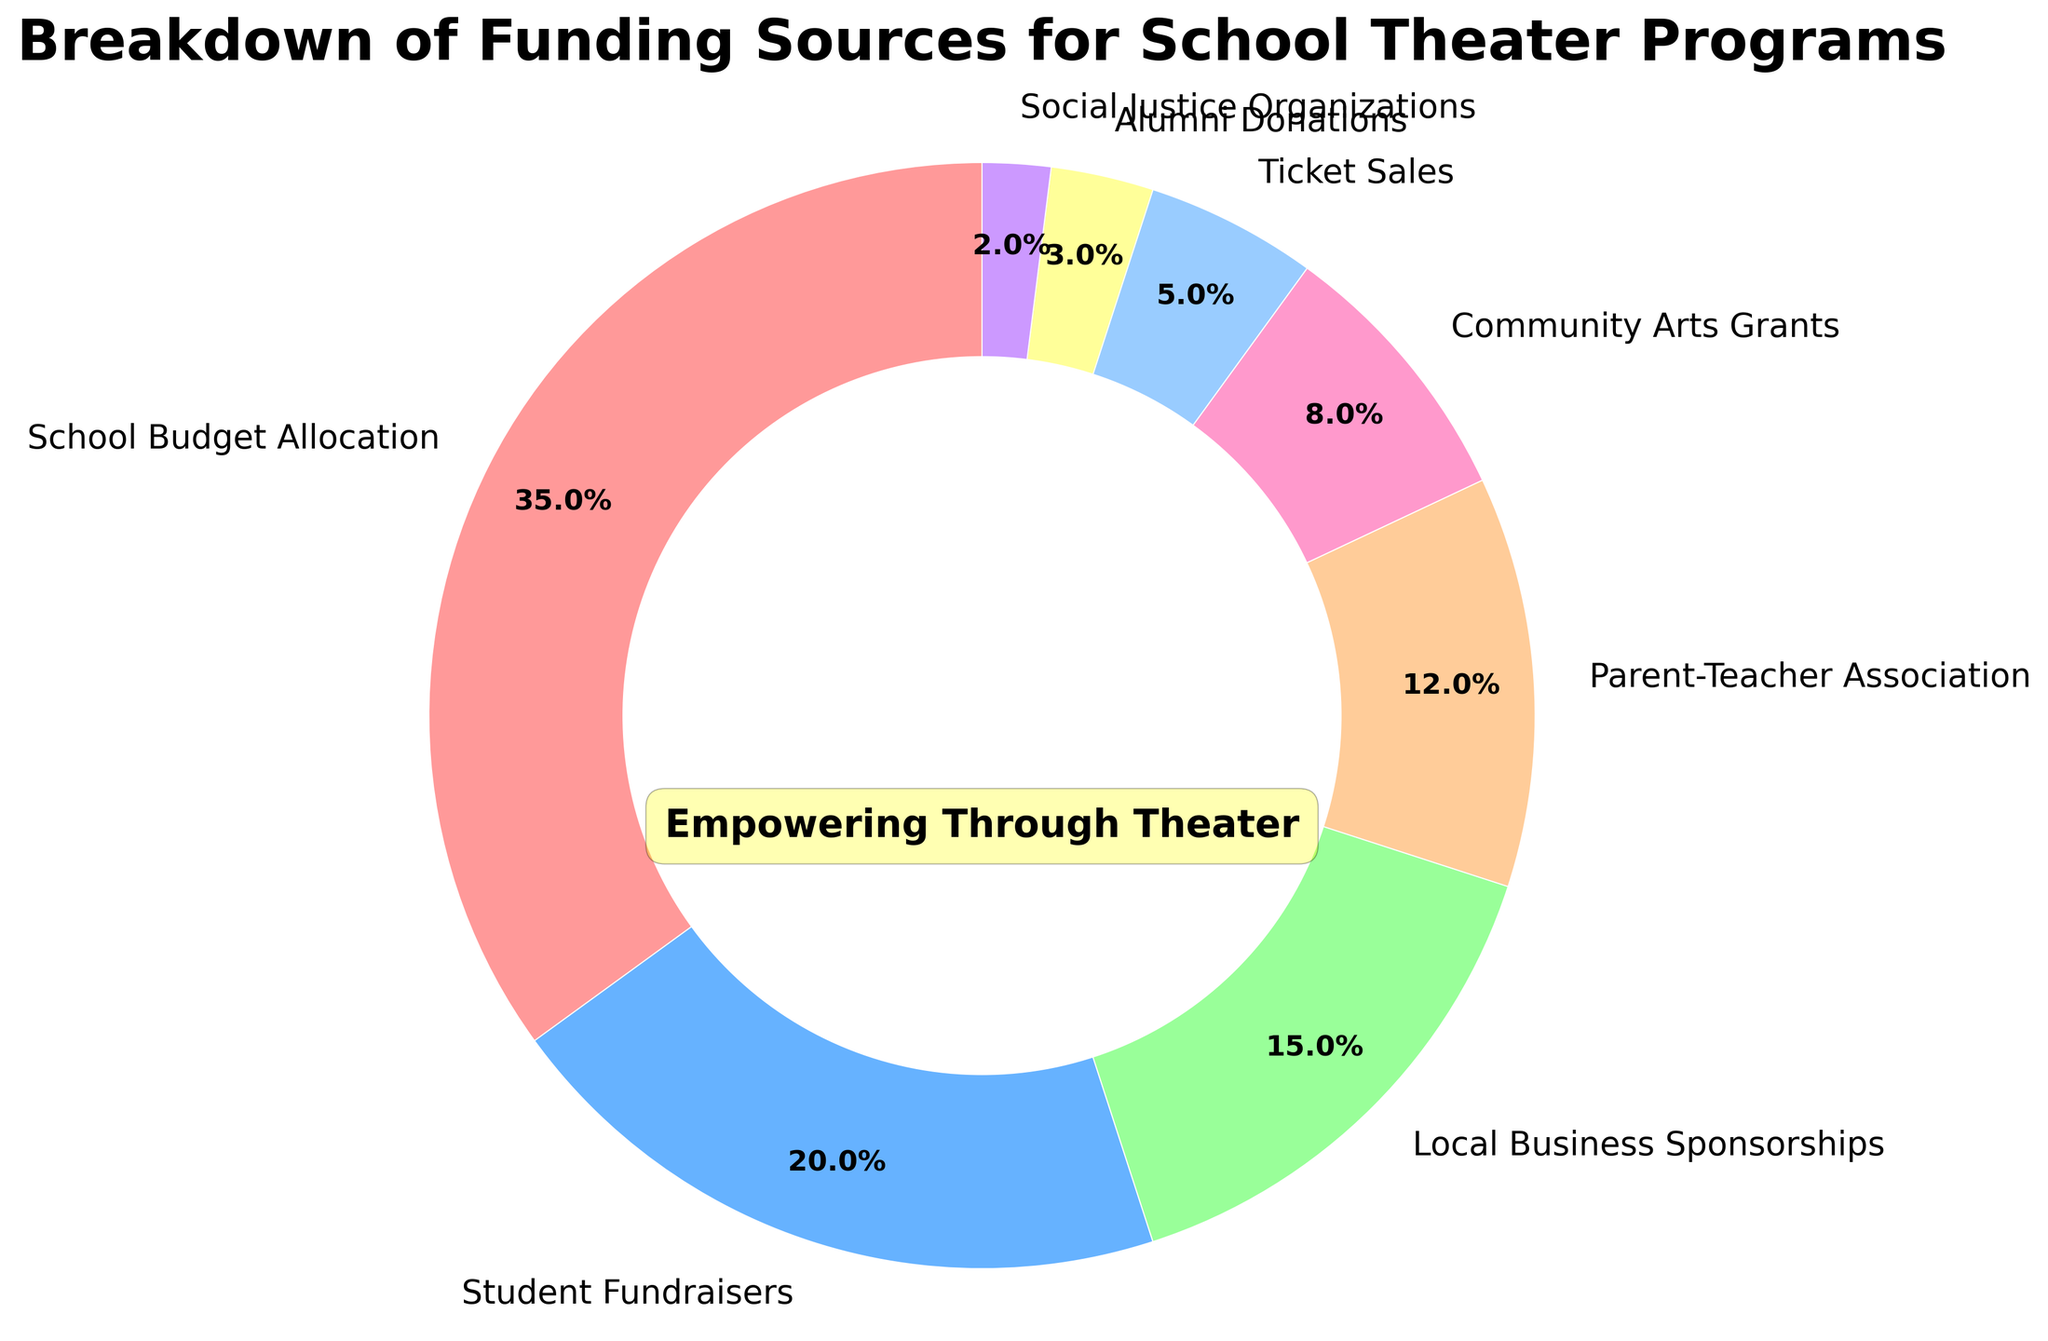What is the largest funding source for school theater programs? The largest segment in the pie chart represents the highest percentage. The label 'School Budget Allocation' is the largest segment with 35%.
Answer: School Budget Allocation Which funding source contributes the least to school theater programs? The smallest segment in the pie chart represents the lowest percentage. The label 'Social Justice Organizations' is the smallest segment with 2%.
Answer: Social Justice Organizations How much higher is the percentage of Student Fundraisers compared to Alumni Donations? Calculate the difference between the percentages of 'Student Fundraisers' and 'Alumni Donations': 20% - 3% = 17%.
Answer: 17% What is the combined percentage of Local Business Sponsorships and Community Arts Grants? Add the percentages of 'Local Business Sponsorships' and 'Community Arts Grants': 15% + 8% = 23%.
Answer: 23% If you were to remove the smallest three funding sources, what percentage of funding would remain? First, sum the smallest three funding sources: Social Justice Organizations (2%), Alumni Donations (3%), and Ticket Sales (5%). This totals 10%. Subtract this from 100%: 100% - 10% = 90%.
Answer: 90% Which funding source is represented with a red section? The pie chart uses a custom color palette where the order of colors matches the order of funding sources. The first color in the palette is red, and it corresponds to 'School Budget Allocation'.
Answer: School Budget Allocation How much more does the Parent-Teacher Association contribute than Ticket Sales? Calculate the difference between the percentages of 'Parent-Teacher Association' and 'Ticket Sales': 12% - 5% = 7%.
Answer: 7% Which funding sources combined contribute to roughly a quarter of the funding? Identify sources which sum up to approximately 25%. 'Local Business Sponsorships' and 'Community Arts Grants' combine to exactly 23% (15% + 8%).
Answer: Local Business Sponsorships and Community Arts Grants Does the contribution from Student Fundraisers exceed that of Local Business Sponsorships? Compare the percentages of 'Student Fundraisers' (20%) and 'Local Business Sponsorships' (15%). The percentage of Student Fundraisers is greater.
Answer: Yes What fraction of the funding comes from Ticket Sales, rounded to the nearest whole number? The percentage of 'Ticket Sales' is 5%. This can be expressed as the fraction 5/100, which simplifies to 1/20.
Answer: 1/20 